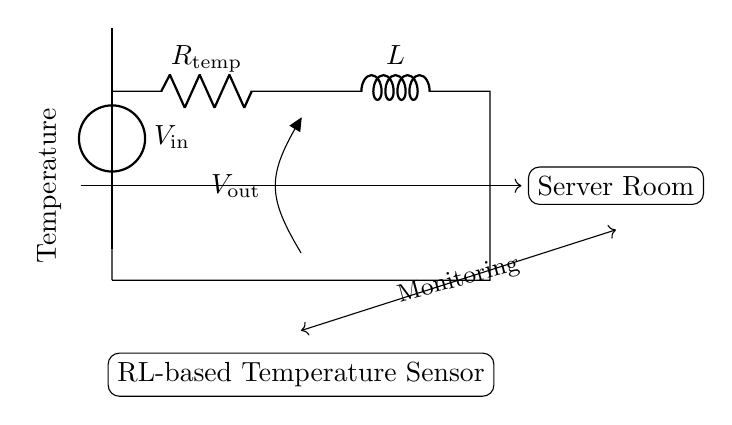What type of components are in this circuit? The circuit contains a resistor and an inductor, which are basic passive components used for various functions, including filtering and sensing.
Answer: resistor and inductor What does the symbol V out represent in the circuit? V out represents the output voltage across the components, indicating the voltage that can be measured or used as an indicator of the circuit's performance.
Answer: output voltage What is the role of the resistor in this RL-based temperature sensing circuit? The resistor limits the current flowing through the circuit and plays a critical role in determining the temperature response based on the physical properties of the resistor material, which changes with temperature.
Answer: current limiting How does the inductor respond to sudden changes in temperature? The inductor resists changes in current flow due to its inductance; so, in response to abrupt temperature changes, it will affect the rate at which the current builds or decays, thereby influencing the output voltage.
Answer: current response What is the significance of the voltage source labeled V in this circuit? The voltage source provides the necessary input energy for the circuit to function, allowing the system to operate and produce an output voltage that can be related to temperature changes.
Answer: power supply How is temperature monitored in this circuit? Temperature is monitored by measuring the output voltage across the resistor, which varies with temperature, allowing for the correlation to temperature readings.
Answer: output voltage measurement What would happen to the output voltage if the temperature increases? As temperature increases, the resistance of the resistor changes (typically increases), which in turn affects the output voltage according to Ohm's law and the circuit's response, generally leading to a predictable change in output.
Answer: output voltage change 